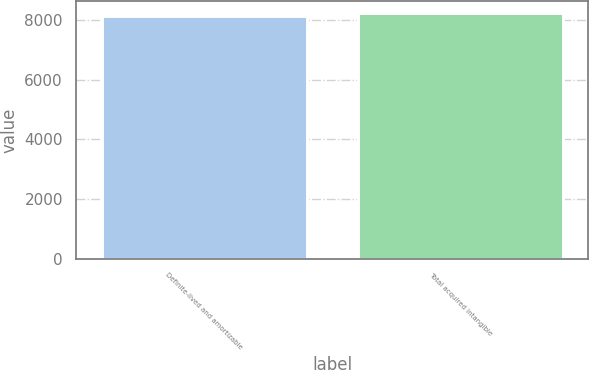Convert chart. <chart><loc_0><loc_0><loc_500><loc_500><bar_chart><fcel>Definite-lived and amortizable<fcel>Total acquired intangible<nl><fcel>8125<fcel>8225<nl></chart> 